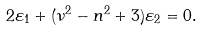Convert formula to latex. <formula><loc_0><loc_0><loc_500><loc_500>2 \varepsilon _ { 1 } + ( \nu ^ { 2 } - n ^ { 2 } + 3 ) \varepsilon _ { 2 } = 0 .</formula> 